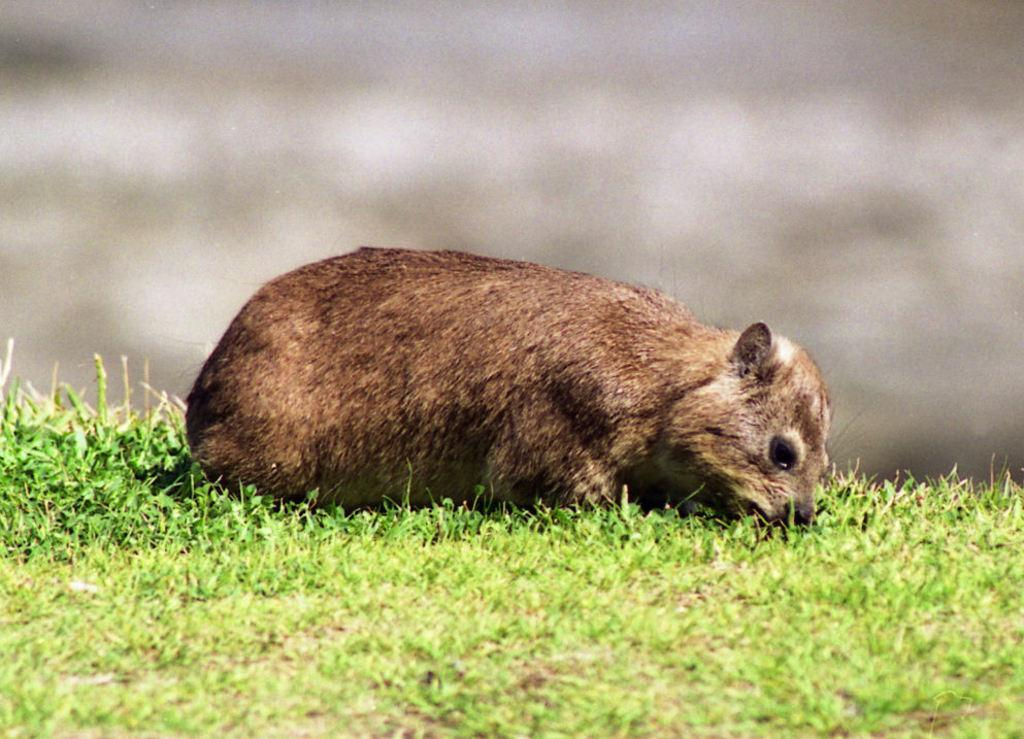What is the main subject of the image? There is an animal lying on the grass in the image. Can you describe the background of the image? The background of the image is blurry. What type of canvas is the animal working on in the image? There is no canvas or work being done by the animal in the image; it is simply lying on the grass. Can you see any bones in the image? There are no bones visible in the image. 